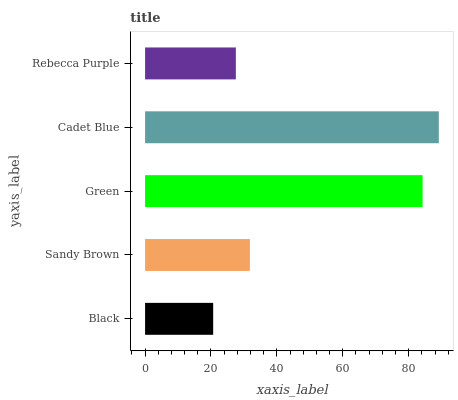Is Black the minimum?
Answer yes or no. Yes. Is Cadet Blue the maximum?
Answer yes or no. Yes. Is Sandy Brown the minimum?
Answer yes or no. No. Is Sandy Brown the maximum?
Answer yes or no. No. Is Sandy Brown greater than Black?
Answer yes or no. Yes. Is Black less than Sandy Brown?
Answer yes or no. Yes. Is Black greater than Sandy Brown?
Answer yes or no. No. Is Sandy Brown less than Black?
Answer yes or no. No. Is Sandy Brown the high median?
Answer yes or no. Yes. Is Sandy Brown the low median?
Answer yes or no. Yes. Is Rebecca Purple the high median?
Answer yes or no. No. Is Black the low median?
Answer yes or no. No. 